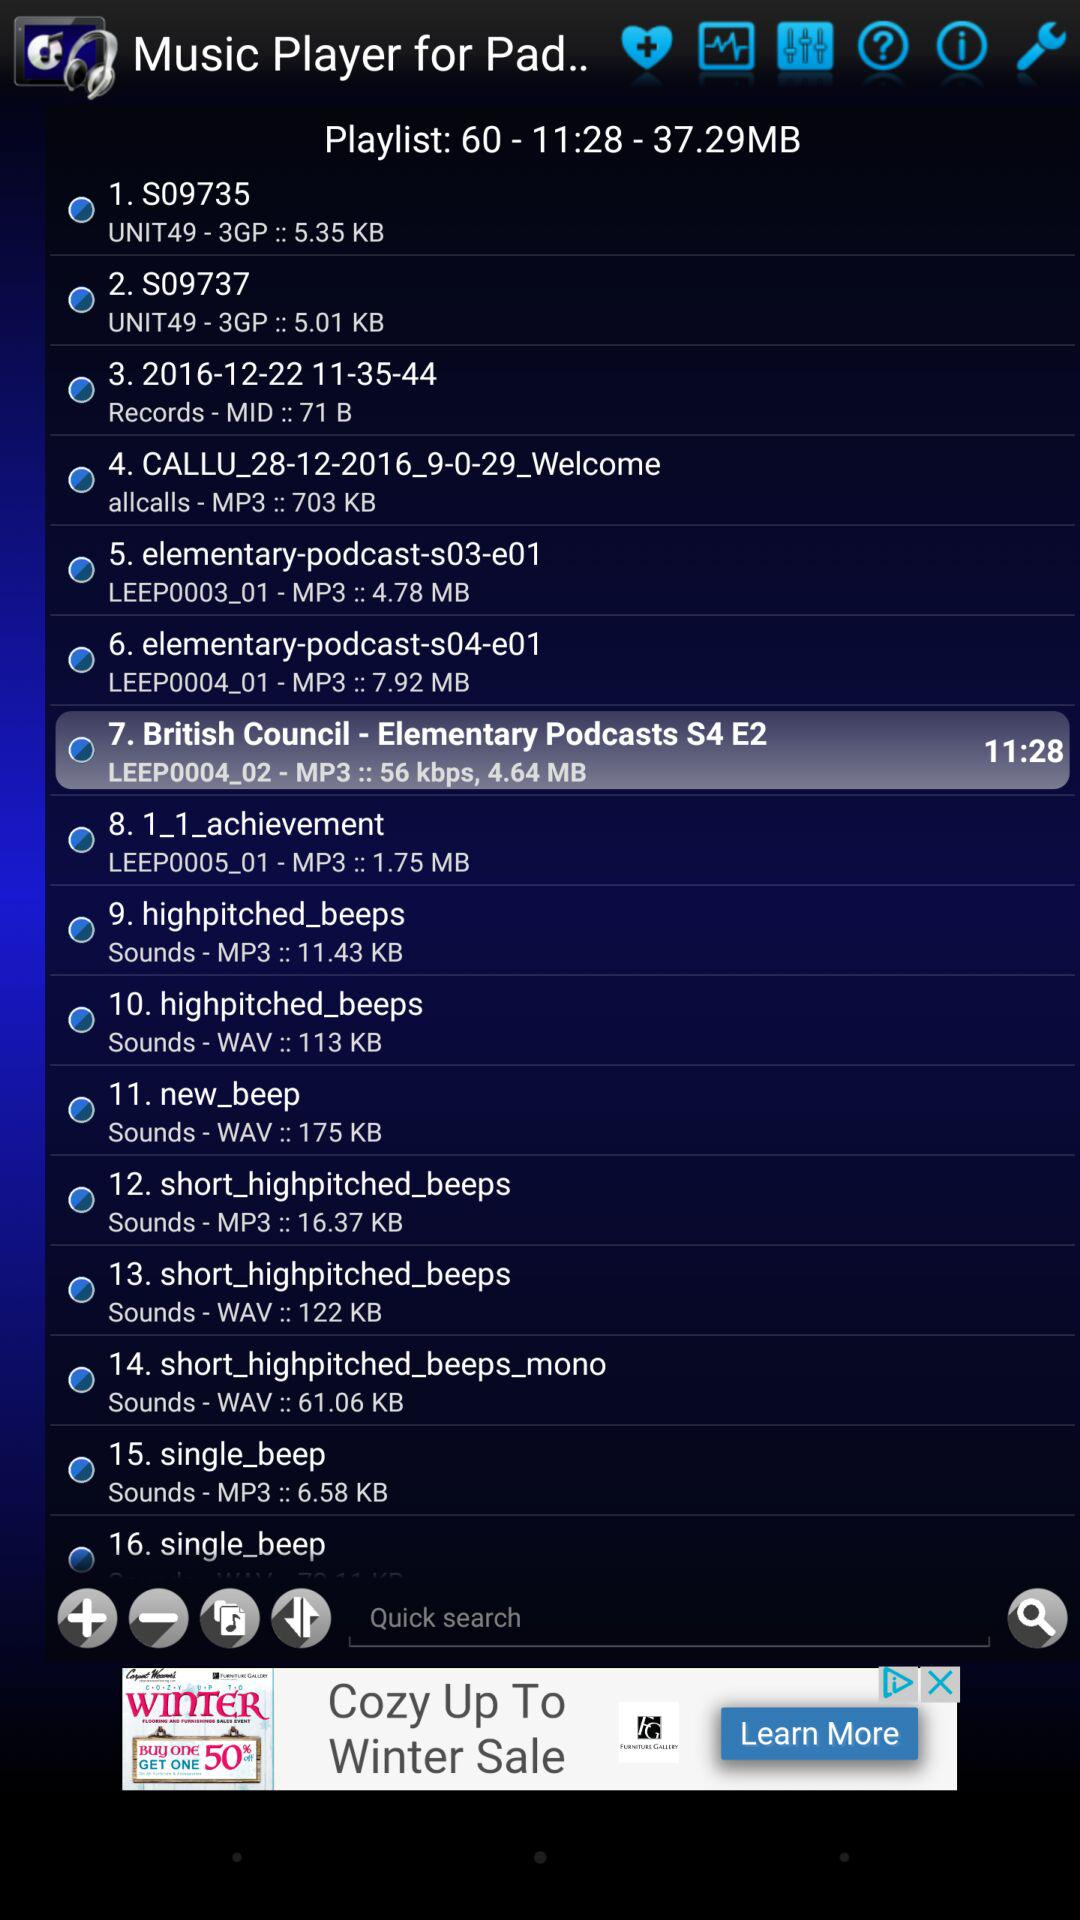What is the format of song number 1 in the playlist? The format is 3GP. 